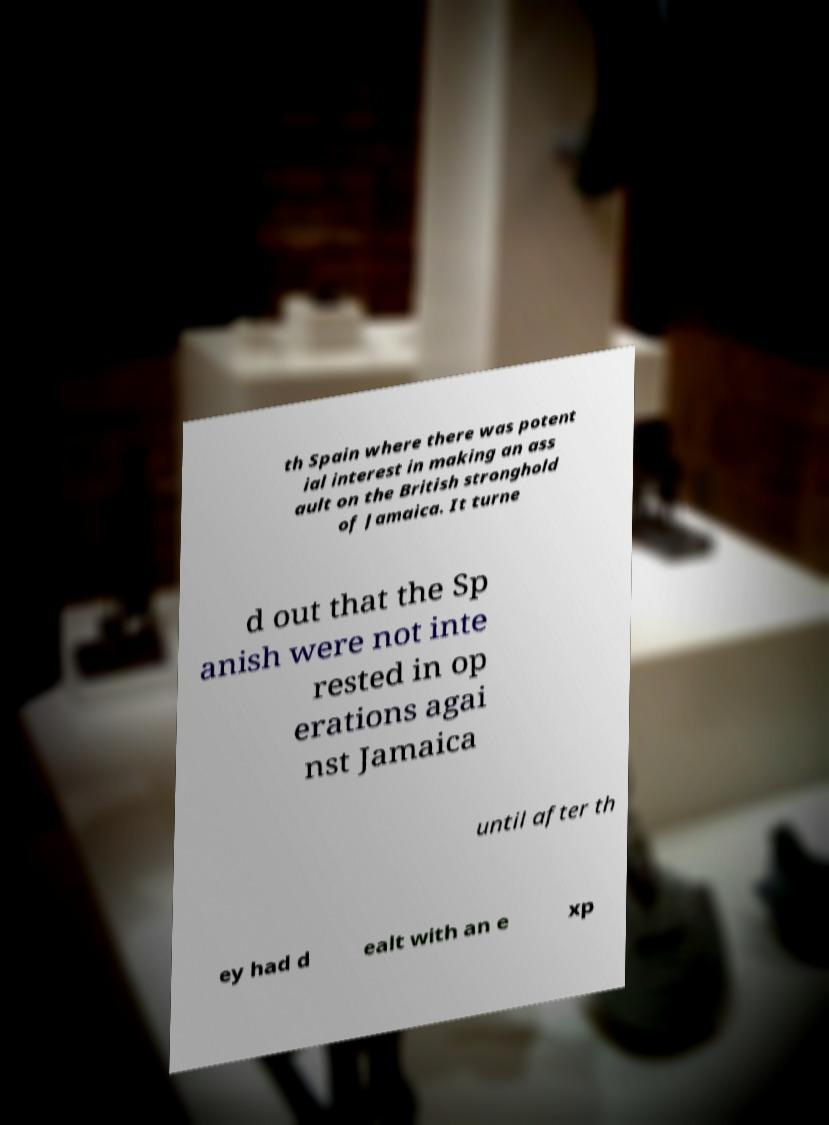What messages or text are displayed in this image? I need them in a readable, typed format. th Spain where there was potent ial interest in making an ass ault on the British stronghold of Jamaica. It turne d out that the Sp anish were not inte rested in op erations agai nst Jamaica until after th ey had d ealt with an e xp 